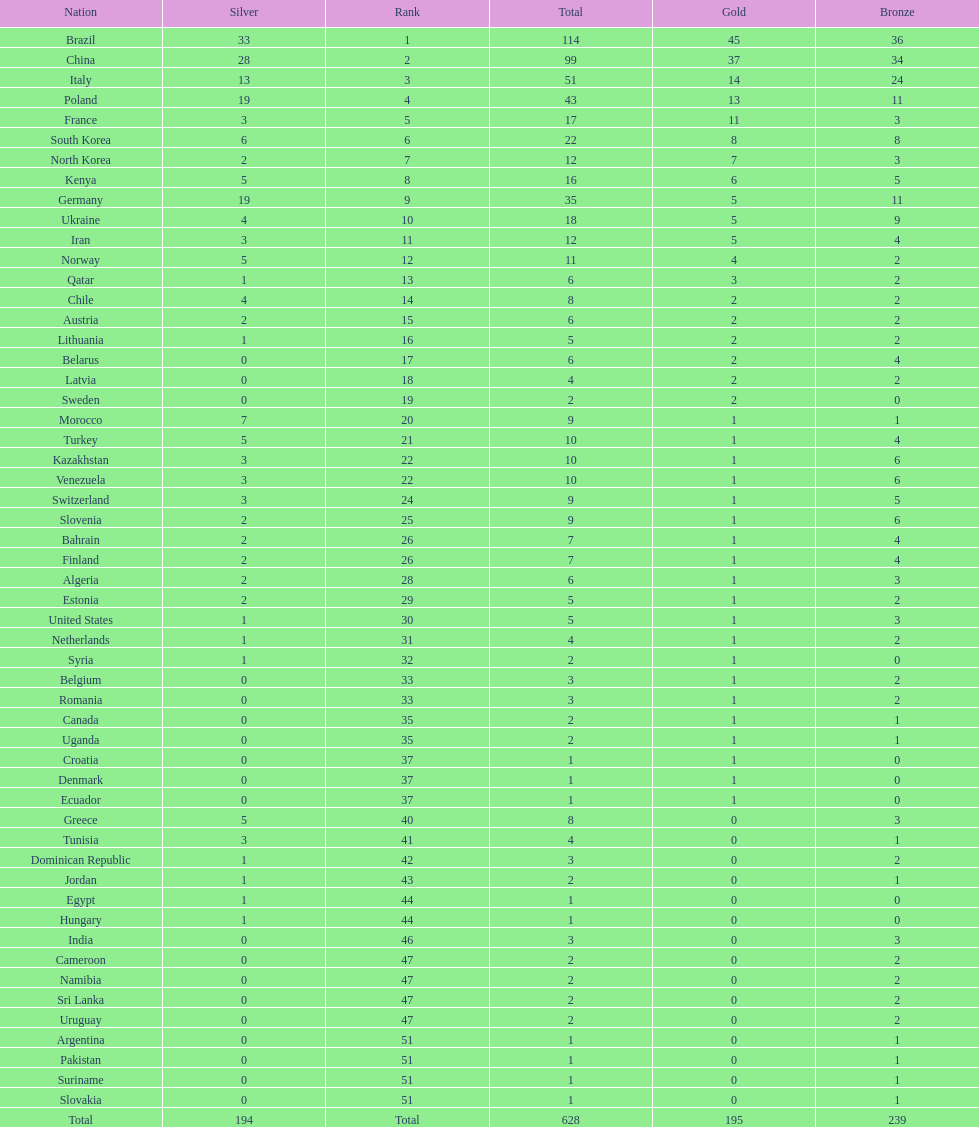Did italy or norway have 51 total medals? Italy. 